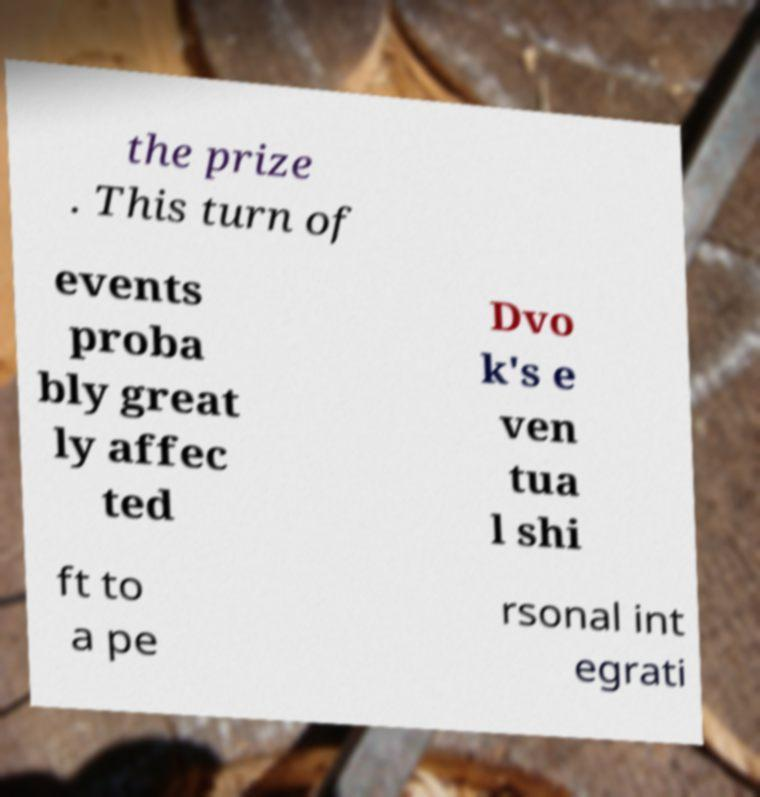There's text embedded in this image that I need extracted. Can you transcribe it verbatim? the prize . This turn of events proba bly great ly affec ted Dvo k's e ven tua l shi ft to a pe rsonal int egrati 